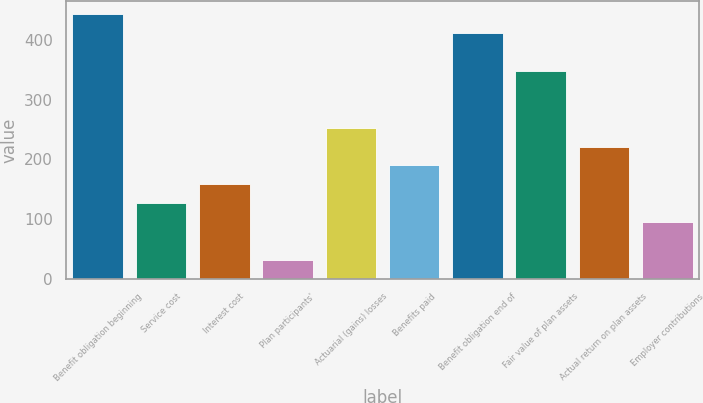Convert chart. <chart><loc_0><loc_0><loc_500><loc_500><bar_chart><fcel>Benefit obligation beginning<fcel>Service cost<fcel>Interest cost<fcel>Plan participants'<fcel>Actuarial (gains) losses<fcel>Benefits paid<fcel>Benefit obligation end of<fcel>Fair value of plan assets<fcel>Actual return on plan assets<fcel>Employer contributions<nl><fcel>443.06<fcel>126.66<fcel>158.3<fcel>31.74<fcel>253.22<fcel>189.94<fcel>411.42<fcel>348.14<fcel>221.58<fcel>95.02<nl></chart> 